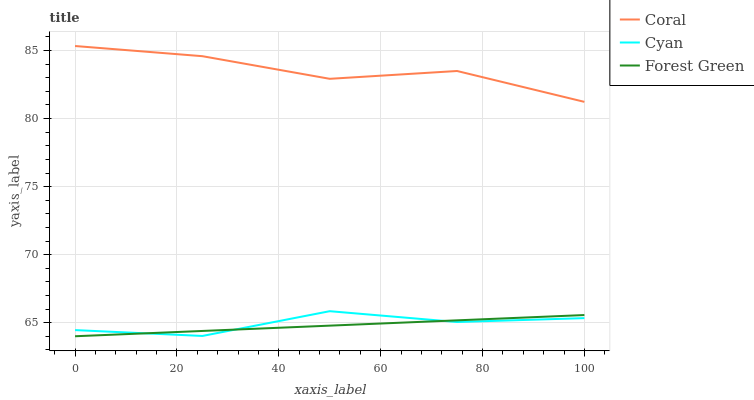Does Forest Green have the minimum area under the curve?
Answer yes or no. Yes. Does Coral have the maximum area under the curve?
Answer yes or no. Yes. Does Coral have the minimum area under the curve?
Answer yes or no. No. Does Forest Green have the maximum area under the curve?
Answer yes or no. No. Is Forest Green the smoothest?
Answer yes or no. Yes. Is Coral the roughest?
Answer yes or no. Yes. Is Coral the smoothest?
Answer yes or no. No. Is Forest Green the roughest?
Answer yes or no. No. Does Forest Green have the lowest value?
Answer yes or no. Yes. Does Coral have the lowest value?
Answer yes or no. No. Does Coral have the highest value?
Answer yes or no. Yes. Does Forest Green have the highest value?
Answer yes or no. No. Is Forest Green less than Coral?
Answer yes or no. Yes. Is Coral greater than Forest Green?
Answer yes or no. Yes. Does Forest Green intersect Cyan?
Answer yes or no. Yes. Is Forest Green less than Cyan?
Answer yes or no. No. Is Forest Green greater than Cyan?
Answer yes or no. No. Does Forest Green intersect Coral?
Answer yes or no. No. 